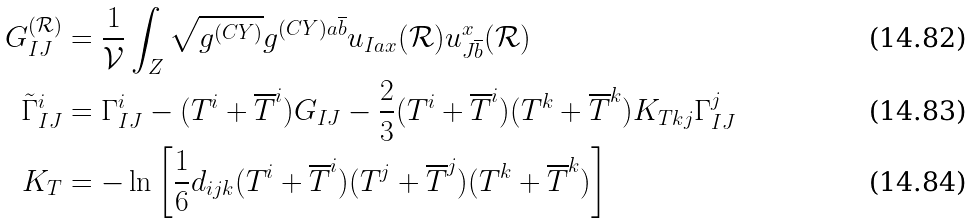Convert formula to latex. <formula><loc_0><loc_0><loc_500><loc_500>G ^ { ( \mathcal { R } ) } _ { I J } & = \frac { 1 } { \mathcal { V } } \int _ { Z } \sqrt { g ^ { ( C Y ) } } g ^ { ( C Y ) a \overline { b } } u _ { I a x } ( \mathcal { R } ) u ^ { x } _ { J \overline { b } } ( \mathcal { R } ) \\ \tilde { \Gamma } ^ { i } _ { I J } & = \Gamma ^ { i } _ { I J } - ( T ^ { i } + \overline { T } ^ { i } ) G _ { I J } - \frac { 2 } { 3 } ( T ^ { i } + \overline { T } ^ { i } ) ( T ^ { k } + \overline { T } ^ { k } ) K _ { T k j } \Gamma ^ { j } _ { I J } \\ K _ { T } & = - \ln \left [ \frac { 1 } { 6 } d _ { i j k } ( T ^ { i } + \overline { T } ^ { i } ) ( T ^ { j } + \overline { T } ^ { j } ) ( T ^ { k } + \overline { T } ^ { k } ) \right ]</formula> 